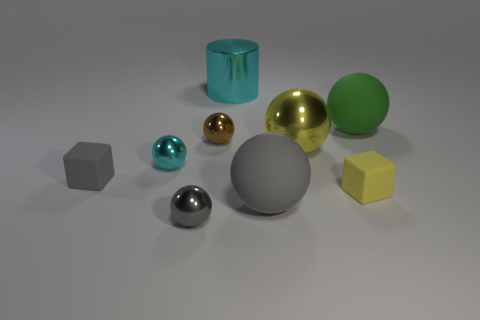How many geometric shapes can you identify in the image? In the image, there are several geometric shapes: I can identify spheres, cubes (including one that appears slightly elongated or stretched into a cuboid), and cylinders. 